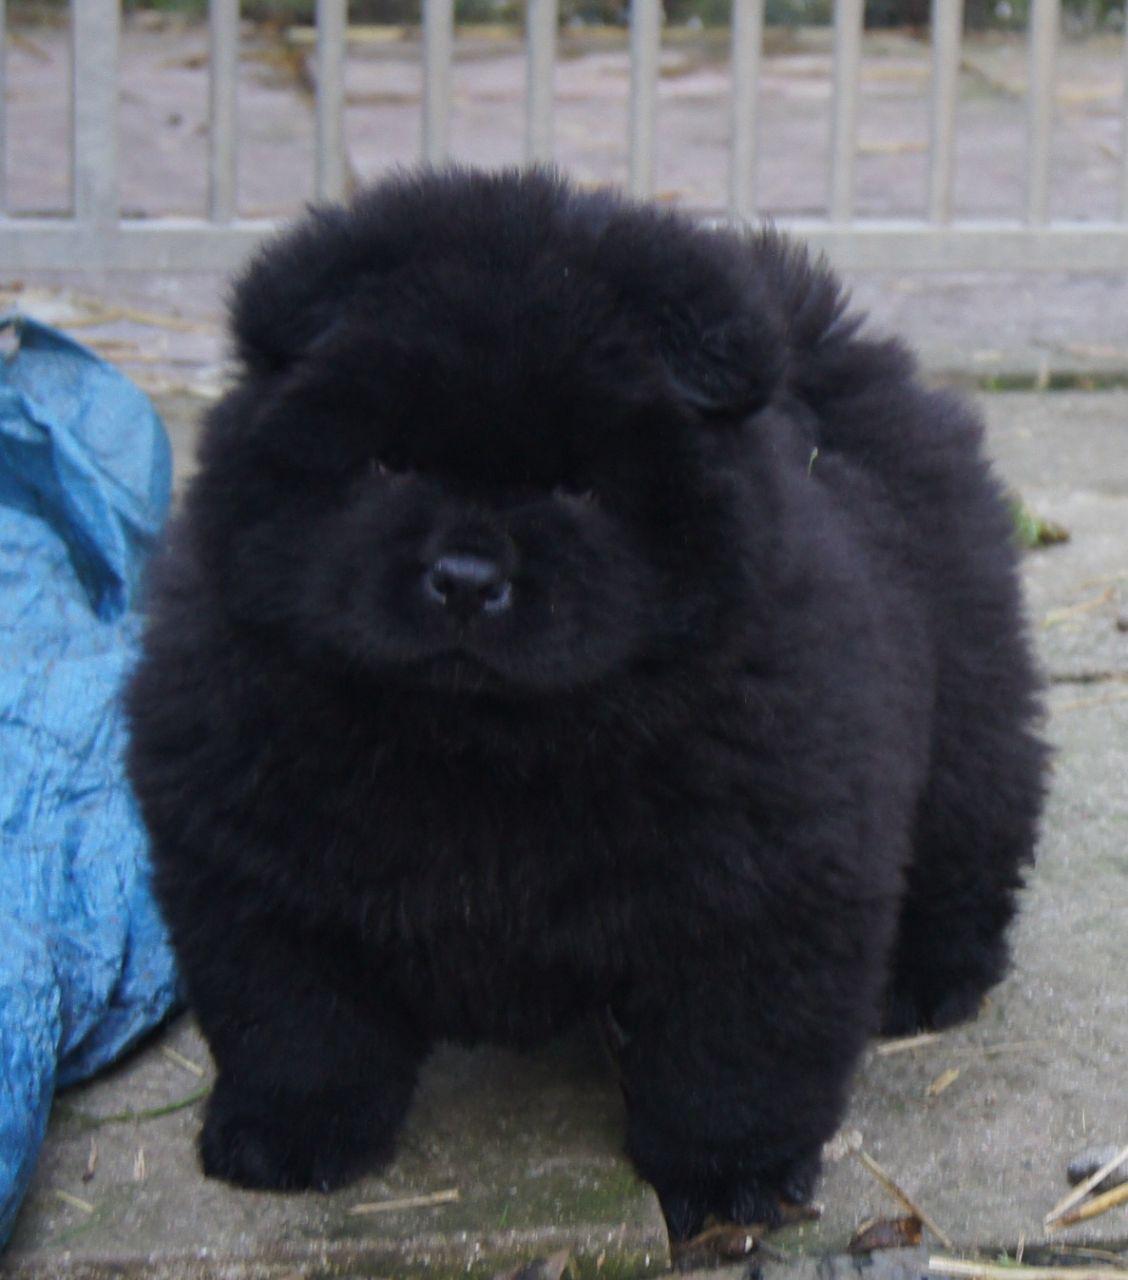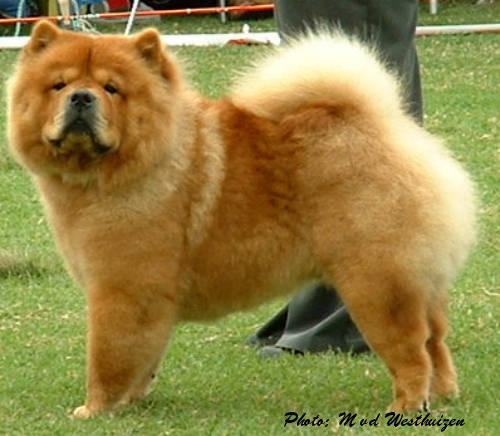The first image is the image on the left, the second image is the image on the right. For the images displayed, is the sentence "The right image contains one adult red-orange chow standing in profile turned leftward, and the left image includes a fluffy young chow facing forward." factually correct? Answer yes or no. Yes. The first image is the image on the left, the second image is the image on the right. For the images shown, is this caption "The left image contains one black chow dog." true? Answer yes or no. Yes. 